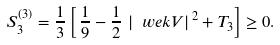Convert formula to latex. <formula><loc_0><loc_0><loc_500><loc_500>S ^ { ( 3 ) } _ { 3 } = \frac { 1 } { 3 } \left [ \, \frac { 1 } { 9 } - \frac { 1 } { 2 } \, \left | \ w e k { V } \right | ^ { \, 2 } + T _ { 3 } \right ] \geq 0 .</formula> 